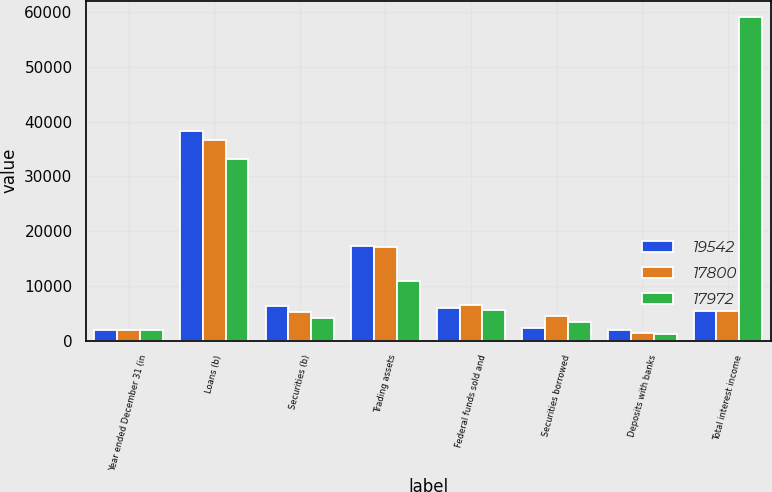<chart> <loc_0><loc_0><loc_500><loc_500><stacked_bar_chart><ecel><fcel>Year ended December 31 (in<fcel>Loans (b)<fcel>Securities (b)<fcel>Trading assets<fcel>Federal funds sold and<fcel>Securities borrowed<fcel>Deposits with banks<fcel>Total interest income<nl><fcel>19542<fcel>2008<fcel>38347<fcel>6344<fcel>17236<fcel>5983<fcel>2297<fcel>1916<fcel>5405<nl><fcel>17800<fcel>2007<fcel>36660<fcel>5232<fcel>17041<fcel>6497<fcel>4539<fcel>1418<fcel>5405<nl><fcel>17972<fcel>2006<fcel>33121<fcel>4147<fcel>10942<fcel>5578<fcel>3402<fcel>1265<fcel>59107<nl></chart> 